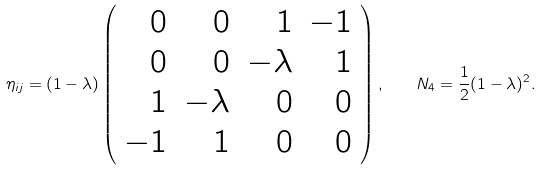Convert formula to latex. <formula><loc_0><loc_0><loc_500><loc_500>\eta _ { i j } = ( 1 - \lambda ) \left ( \begin{array} { r r r r } 0 & 0 & 1 & - 1 \\ 0 & 0 & - \lambda & 1 \\ 1 & - \lambda & 0 & 0 \\ - 1 & 1 & 0 & 0 \end{array} \right ) , \quad N _ { 4 } = \frac { 1 } { 2 } ( 1 - \lambda ) ^ { 2 } .</formula> 